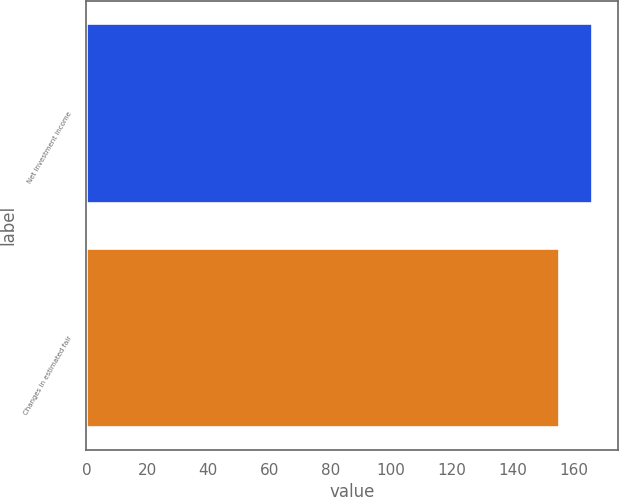Convert chart to OTSL. <chart><loc_0><loc_0><loc_500><loc_500><bar_chart><fcel>Net investment income<fcel>Changes in estimated fair<nl><fcel>166<fcel>155<nl></chart> 